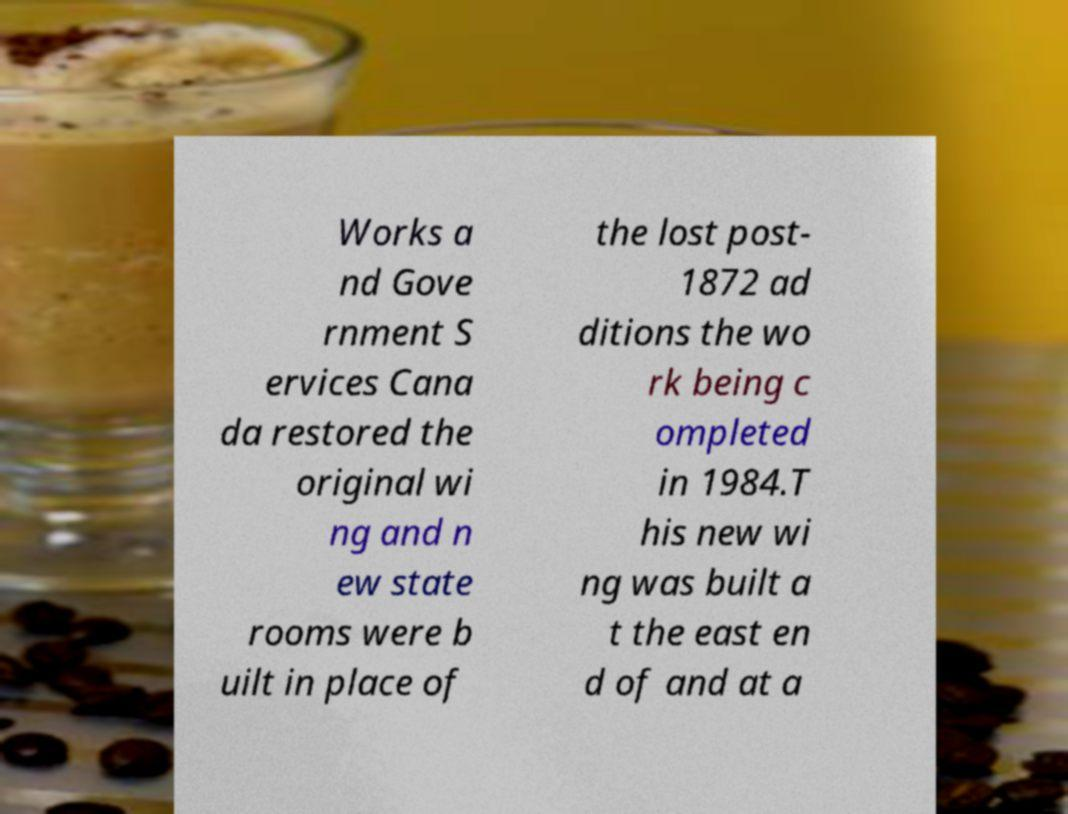Could you extract and type out the text from this image? Works a nd Gove rnment S ervices Cana da restored the original wi ng and n ew state rooms were b uilt in place of the lost post- 1872 ad ditions the wo rk being c ompleted in 1984.T his new wi ng was built a t the east en d of and at a 